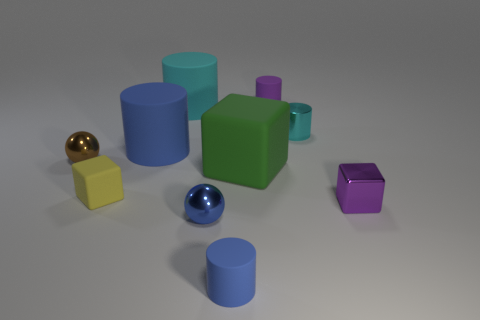What number of tiny objects have the same shape as the big blue matte object?
Your response must be concise. 3. Is the number of large green blocks right of the small purple rubber object the same as the number of metal spheres that are in front of the green rubber thing?
Your answer should be compact. No. What is the shape of the blue thing behind the metallic ball on the right side of the yellow matte thing?
Provide a short and direct response. Cylinder. There is a tiny purple thing that is the same shape as the large blue rubber thing; what material is it?
Offer a very short reply. Rubber. The shiny cylinder that is the same size as the purple matte cylinder is what color?
Ensure brevity in your answer.  Cyan. Is the number of brown things that are behind the tiny purple cylinder the same as the number of large red spheres?
Provide a succinct answer. Yes. There is a small cube on the left side of the cube to the right of the tiny purple matte cylinder; what color is it?
Ensure brevity in your answer.  Yellow. What is the size of the cyan cylinder that is right of the blue matte cylinder in front of the tiny purple metallic block?
Offer a terse response. Small. The thing that is the same color as the tiny metallic cube is what size?
Provide a short and direct response. Small. How many other objects are there of the same size as the cyan matte thing?
Provide a succinct answer. 2. 